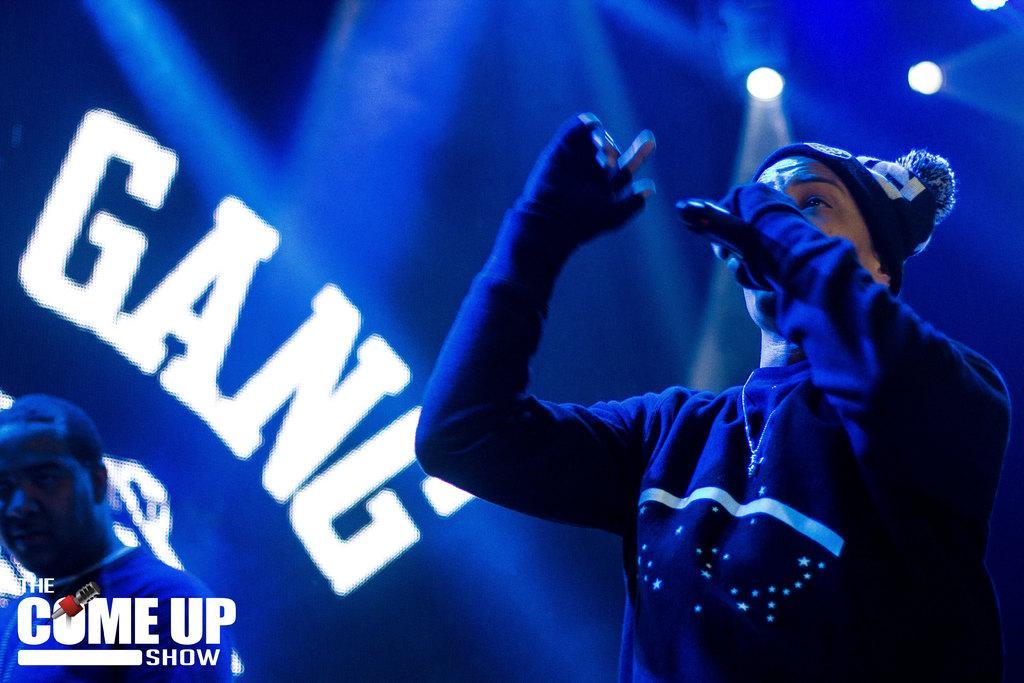Could you give a brief overview of what you see in this image? This is the man standing and holding a mike. I think he is singing a song. He wore a T-shirt and a cap. These are the show lights. I think this is a poster with a name on it. On the left side of the image, I can see another person standing. This is the watermark on the image. 